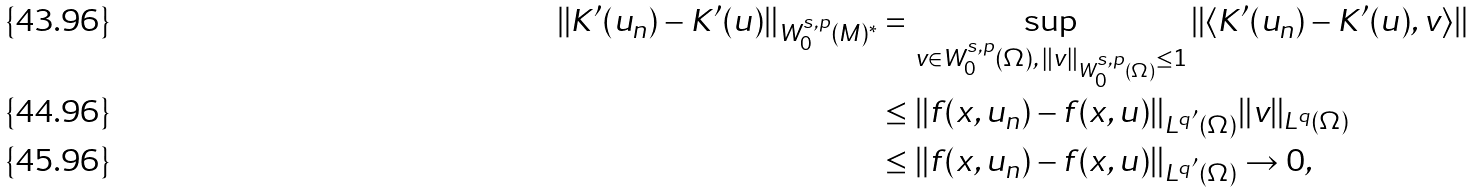Convert formula to latex. <formula><loc_0><loc_0><loc_500><loc_500>\| K ^ { \prime } ( u _ { n } ) - K ^ { \prime } ( u ) \| _ { W _ { 0 } ^ { s , p } ( M ) ^ { * } } & = \sup _ { v \in W _ { 0 } ^ { s , p } ( \Omega ) , \, \| v \| _ { W _ { 0 } ^ { s , p } ( \Omega ) } \leq 1 } \| \langle K ^ { \prime } ( u _ { n } ) - K ^ { \prime } ( u ) , v \rangle \| \\ & \leq \| f ( x , u _ { n } ) - f ( x , u ) \| _ { L ^ { q ^ { \prime } } ( \Omega ) } \| v \| _ { L ^ { q } ( \Omega ) } \\ & \leq \| f ( x , u _ { n } ) - f ( x , u ) \| _ { L ^ { q ^ { \prime } } ( \Omega ) } \to 0 ,</formula> 